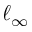Convert formula to latex. <formula><loc_0><loc_0><loc_500><loc_500>\ell _ { \infty }</formula> 